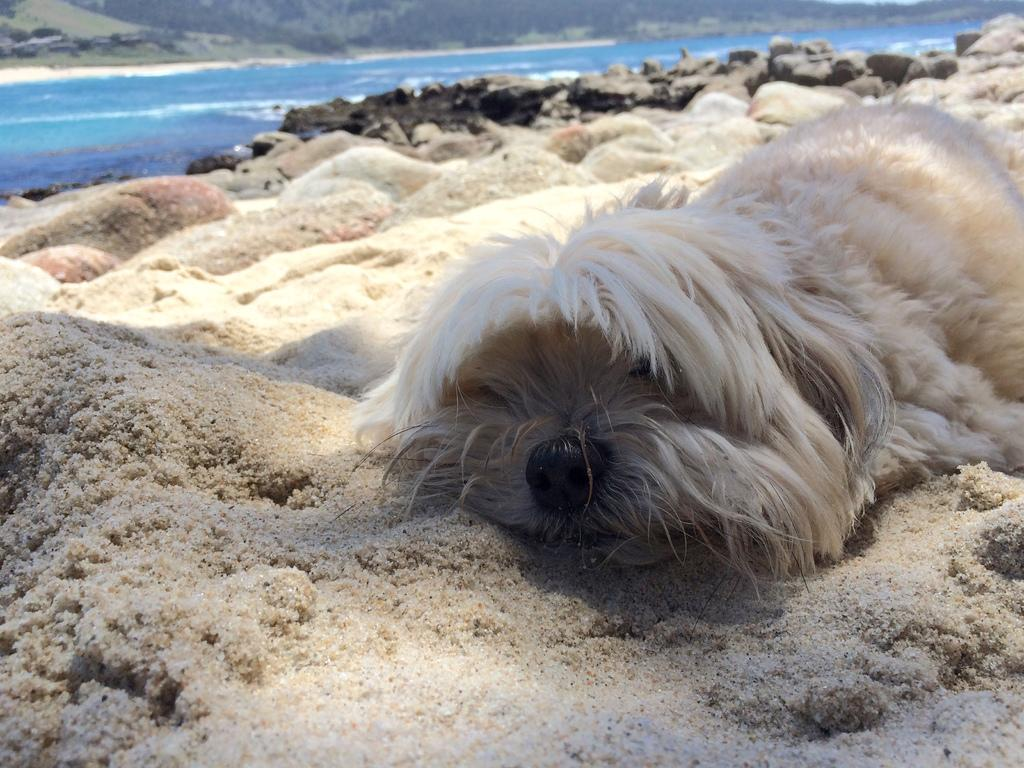What type of natural elements can be seen in the image? There are rocks in the image. What type of animal is present in the image? There is a dog in the image. What can be seen in the background of the image? There is water visible in the image. What caused the dog's death in the image? There is no indication of a dog's death in the image, and no cause can be determined. Where is the hospital located in the image? There is no hospital present in the image. 